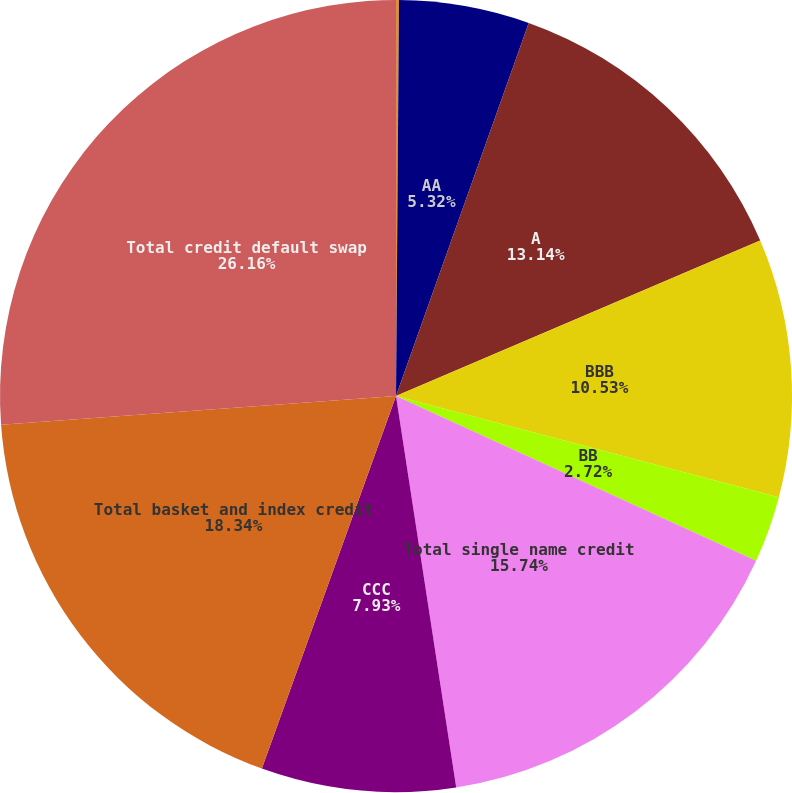<chart> <loc_0><loc_0><loc_500><loc_500><pie_chart><fcel>AAA<fcel>AA<fcel>A<fcel>BBB<fcel>BB<fcel>Total single name credit<fcel>CCC<fcel>Total basket and index credit<fcel>Total credit default swap<nl><fcel>0.12%<fcel>5.32%<fcel>13.14%<fcel>10.53%<fcel>2.72%<fcel>15.74%<fcel>7.93%<fcel>18.34%<fcel>26.16%<nl></chart> 